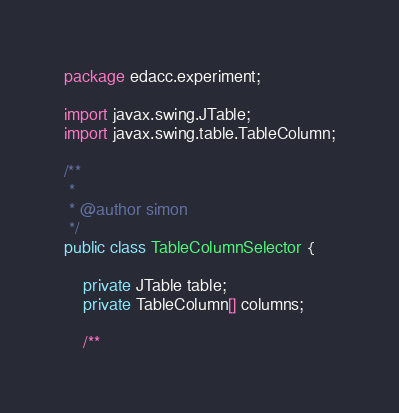<code> <loc_0><loc_0><loc_500><loc_500><_Java_>package edacc.experiment;

import javax.swing.JTable;
import javax.swing.table.TableColumn;

/**
 *
 * @author simon
 */
public class TableColumnSelector {

    private JTable table;
    private TableColumn[] columns;

    /**</code> 